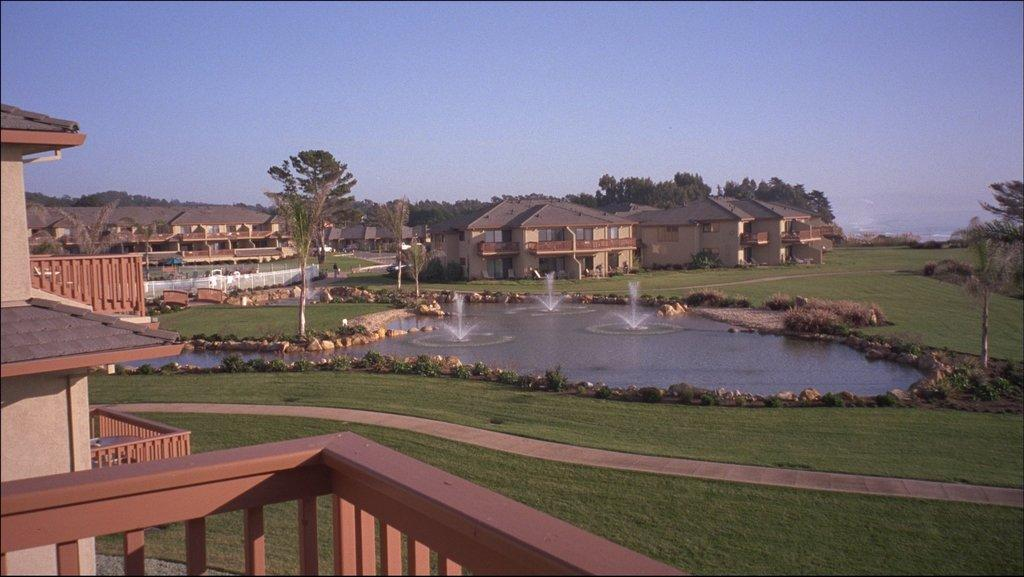What type of structures can be seen in the image? There are many buildings in the image. What other natural elements are present in the image? There are trees and grass visible in the image. Is there a designated walking area in the image? Yes, there is a path in the image. What additional feature can be found in the image? There is a water fountain in the image. What is the color of the sky in the image? The sky is pale blue in the image. Where is the mom standing in the image? There is no mom present in the image. What type of boot is visible on the path in the image? There are no boots visible in the image. 